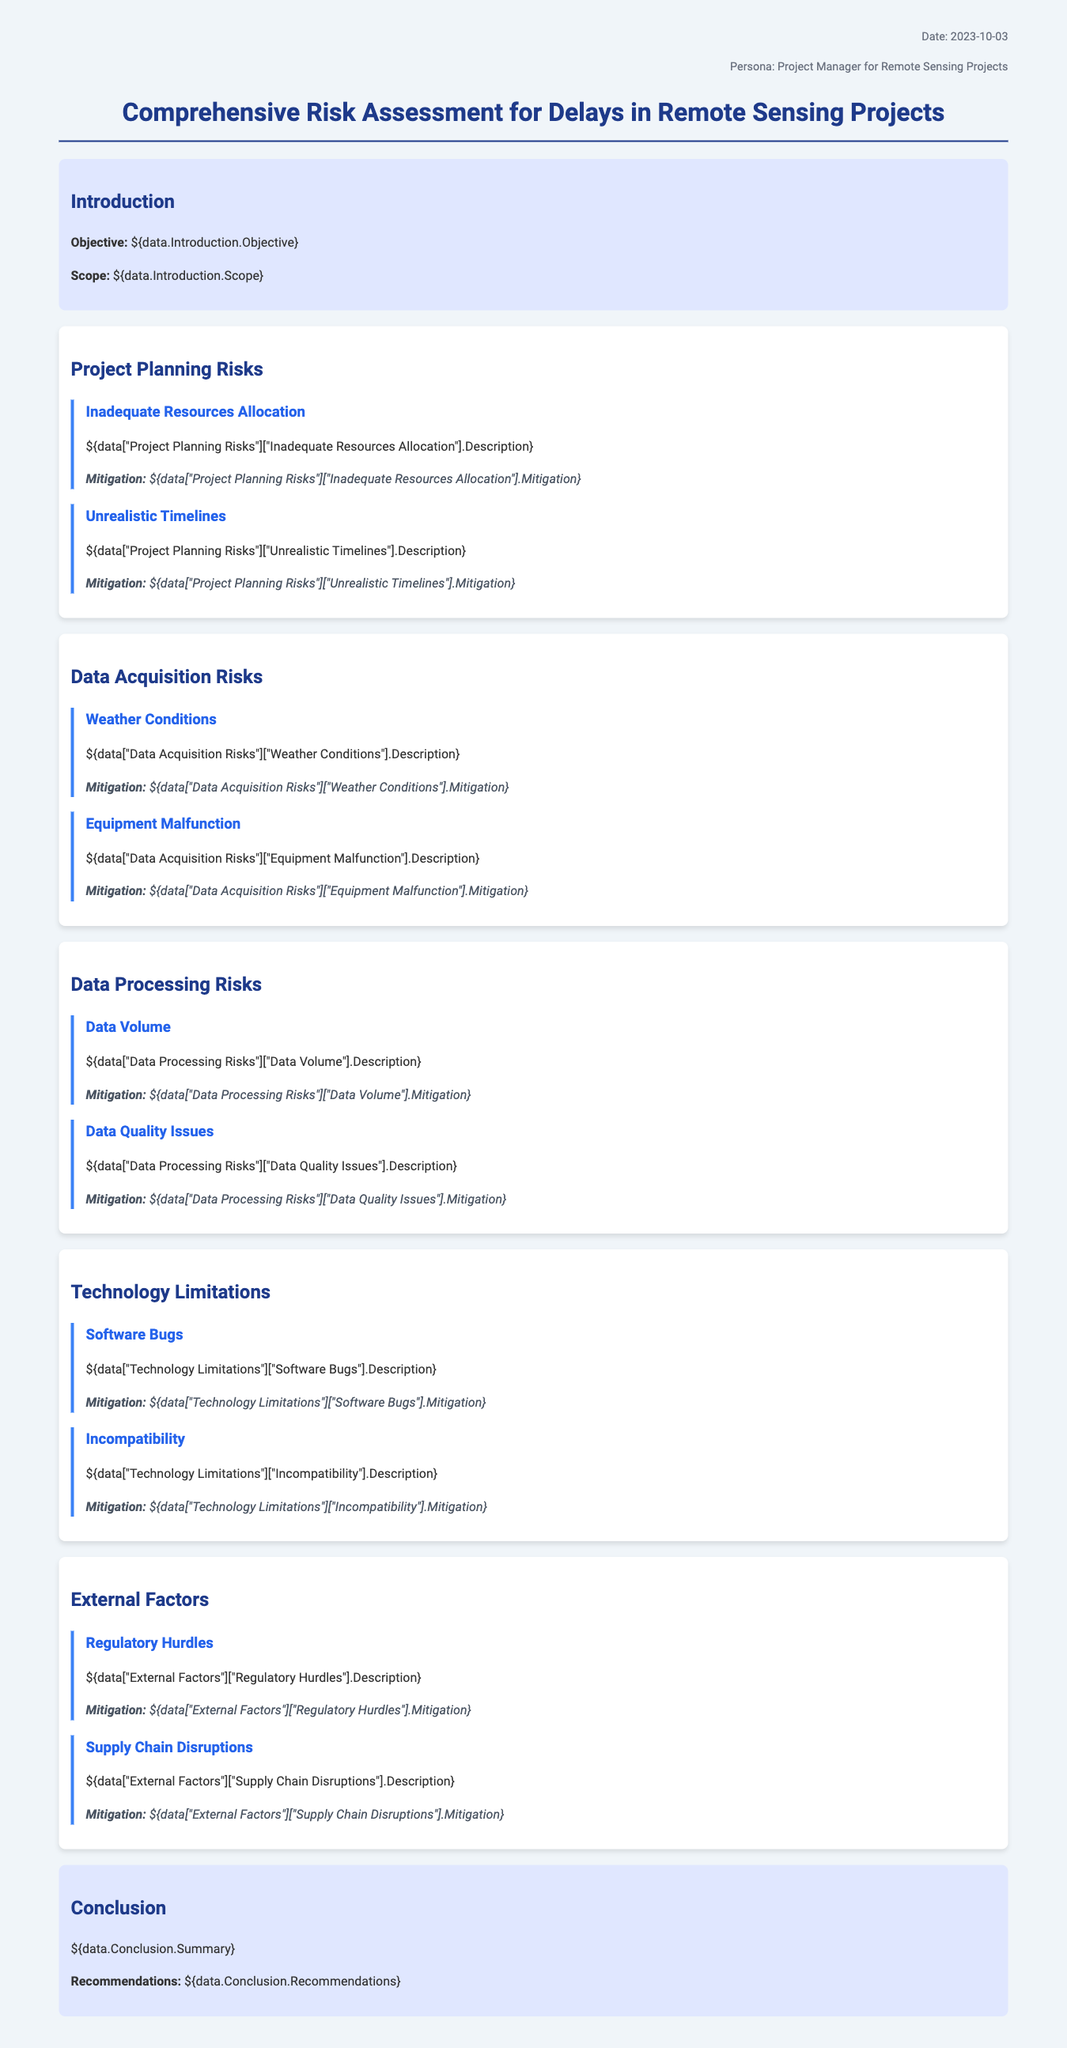What is the date of the document? The date is mentioned in the header info section of the document.
Answer: 2023-10-03 What is the primary objective of the risk assessment? The objective is stated in the introduction of the document.
Answer: To evaluate risks in data acquisition and processing What type of risk is associated with "Inadequate Resources Allocation"? This risk is categorized under Project Planning Risks in the document.
Answer: Project Planning Risk What are the two mitigation strategies for weather conditions? Mitigation strategies are provided in the Data Acquisition Risks section.
Answer: Adjusting schedules and using alternative data sources How many risks are listed under Data Processing Risks? The number of risks can be counted from the Data Processing Risks section of the document.
Answer: Two What is one external factor that could cause delays? The document lists various external factors; one example should be identified.
Answer: Regulatory Hurdles What is the key theme of the conclusion section? The conclusion summarizes important points from the risk assessment.
Answer: Summary and recommendations Which technology limitation is highlighted in the document? The technology limitations section lists specific issues.
Answer: Software Bugs 